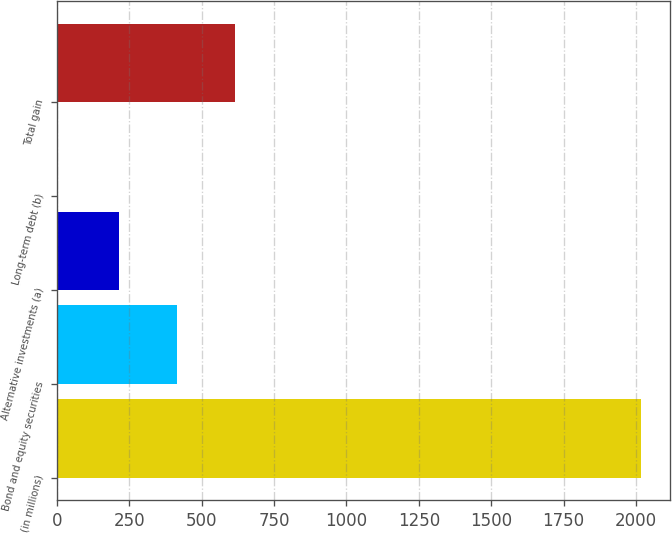<chart> <loc_0><loc_0><loc_500><loc_500><bar_chart><fcel>(in millions)<fcel>Bond and equity securities<fcel>Alternative investments (a)<fcel>Long-term debt (b)<fcel>Total gain<nl><fcel>2018<fcel>414.7<fcel>213<fcel>1<fcel>616.4<nl></chart> 